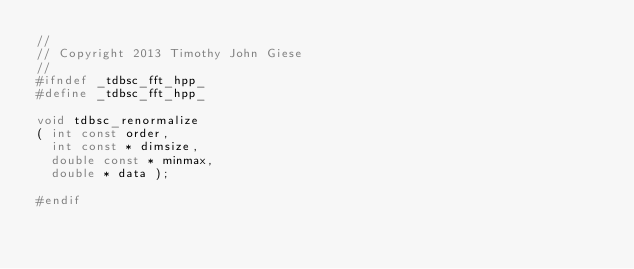<code> <loc_0><loc_0><loc_500><loc_500><_C++_>//
// Copyright 2013 Timothy John Giese
//
#ifndef _tdbsc_fft_hpp_
#define _tdbsc_fft_hpp_

void tdbsc_renormalize
( int const order, 
  int const * dimsize,
  double const * minmax,
  double * data );

#endif
</code> 